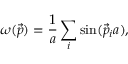<formula> <loc_0><loc_0><loc_500><loc_500>\omega ( \vec { p } ) = { \frac { 1 } { a } } \sum _ { i } \sin ( \vec { p } _ { i } a ) ,</formula> 